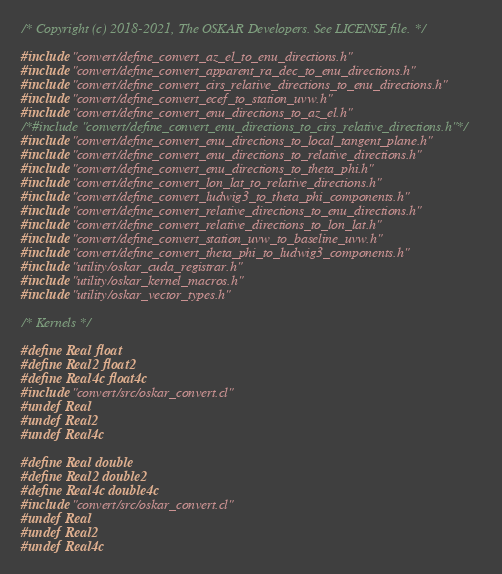Convert code to text. <code><loc_0><loc_0><loc_500><loc_500><_Cuda_>/* Copyright (c) 2018-2021, The OSKAR Developers. See LICENSE file. */

#include "convert/define_convert_az_el_to_enu_directions.h"
#include "convert/define_convert_apparent_ra_dec_to_enu_directions.h"
#include "convert/define_convert_cirs_relative_directions_to_enu_directions.h"
#include "convert/define_convert_ecef_to_station_uvw.h"
#include "convert/define_convert_enu_directions_to_az_el.h"
/*#include "convert/define_convert_enu_directions_to_cirs_relative_directions.h"*/
#include "convert/define_convert_enu_directions_to_local_tangent_plane.h"
#include "convert/define_convert_enu_directions_to_relative_directions.h"
#include "convert/define_convert_enu_directions_to_theta_phi.h"
#include "convert/define_convert_lon_lat_to_relative_directions.h"
#include "convert/define_convert_ludwig3_to_theta_phi_components.h"
#include "convert/define_convert_relative_directions_to_enu_directions.h"
#include "convert/define_convert_relative_directions_to_lon_lat.h"
#include "convert/define_convert_station_uvw_to_baseline_uvw.h"
#include "convert/define_convert_theta_phi_to_ludwig3_components.h"
#include "utility/oskar_cuda_registrar.h"
#include "utility/oskar_kernel_macros.h"
#include "utility/oskar_vector_types.h"

/* Kernels */

#define Real float
#define Real2 float2
#define Real4c float4c
#include "convert/src/oskar_convert.cl"
#undef Real
#undef Real2
#undef Real4c

#define Real double
#define Real2 double2
#define Real4c double4c
#include "convert/src/oskar_convert.cl"
#undef Real
#undef Real2
#undef Real4c
</code> 